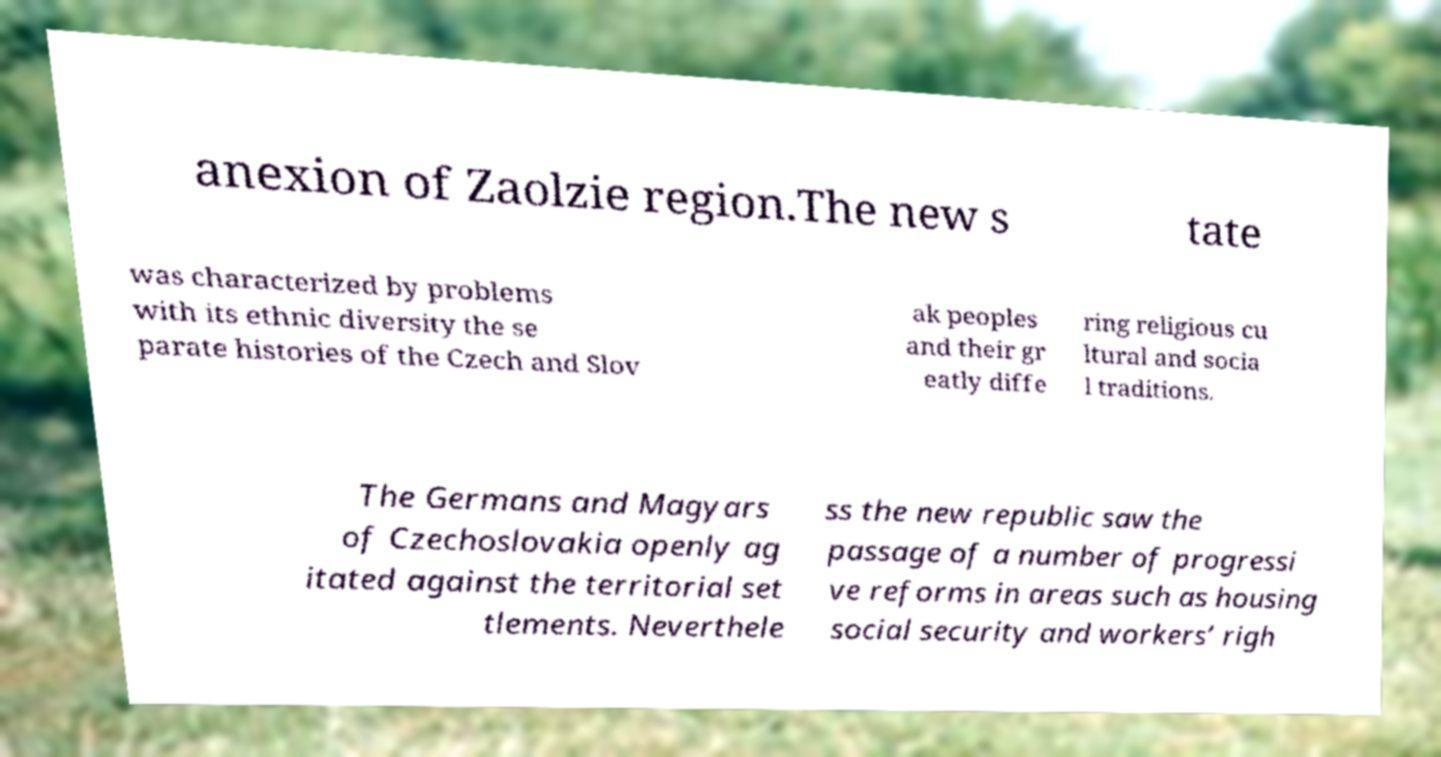I need the written content from this picture converted into text. Can you do that? anexion of Zaolzie region.The new s tate was characterized by problems with its ethnic diversity the se parate histories of the Czech and Slov ak peoples and their gr eatly diffe ring religious cu ltural and socia l traditions. The Germans and Magyars of Czechoslovakia openly ag itated against the territorial set tlements. Neverthele ss the new republic saw the passage of a number of progressi ve reforms in areas such as housing social security and workers’ righ 